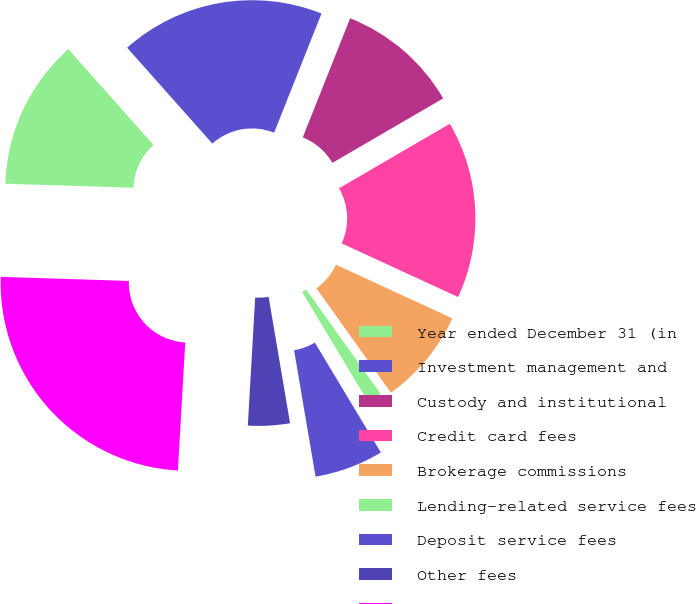Convert chart. <chart><loc_0><loc_0><loc_500><loc_500><pie_chart><fcel>Year ended December 31 (in<fcel>Investment management and<fcel>Custody and institutional<fcel>Credit card fees<fcel>Brokerage commissions<fcel>Lending-related service fees<fcel>Deposit service fees<fcel>Other fees<fcel>Total fees and commissions<nl><fcel>12.93%<fcel>17.59%<fcel>10.59%<fcel>15.26%<fcel>8.26%<fcel>1.26%<fcel>5.93%<fcel>3.59%<fcel>24.59%<nl></chart> 